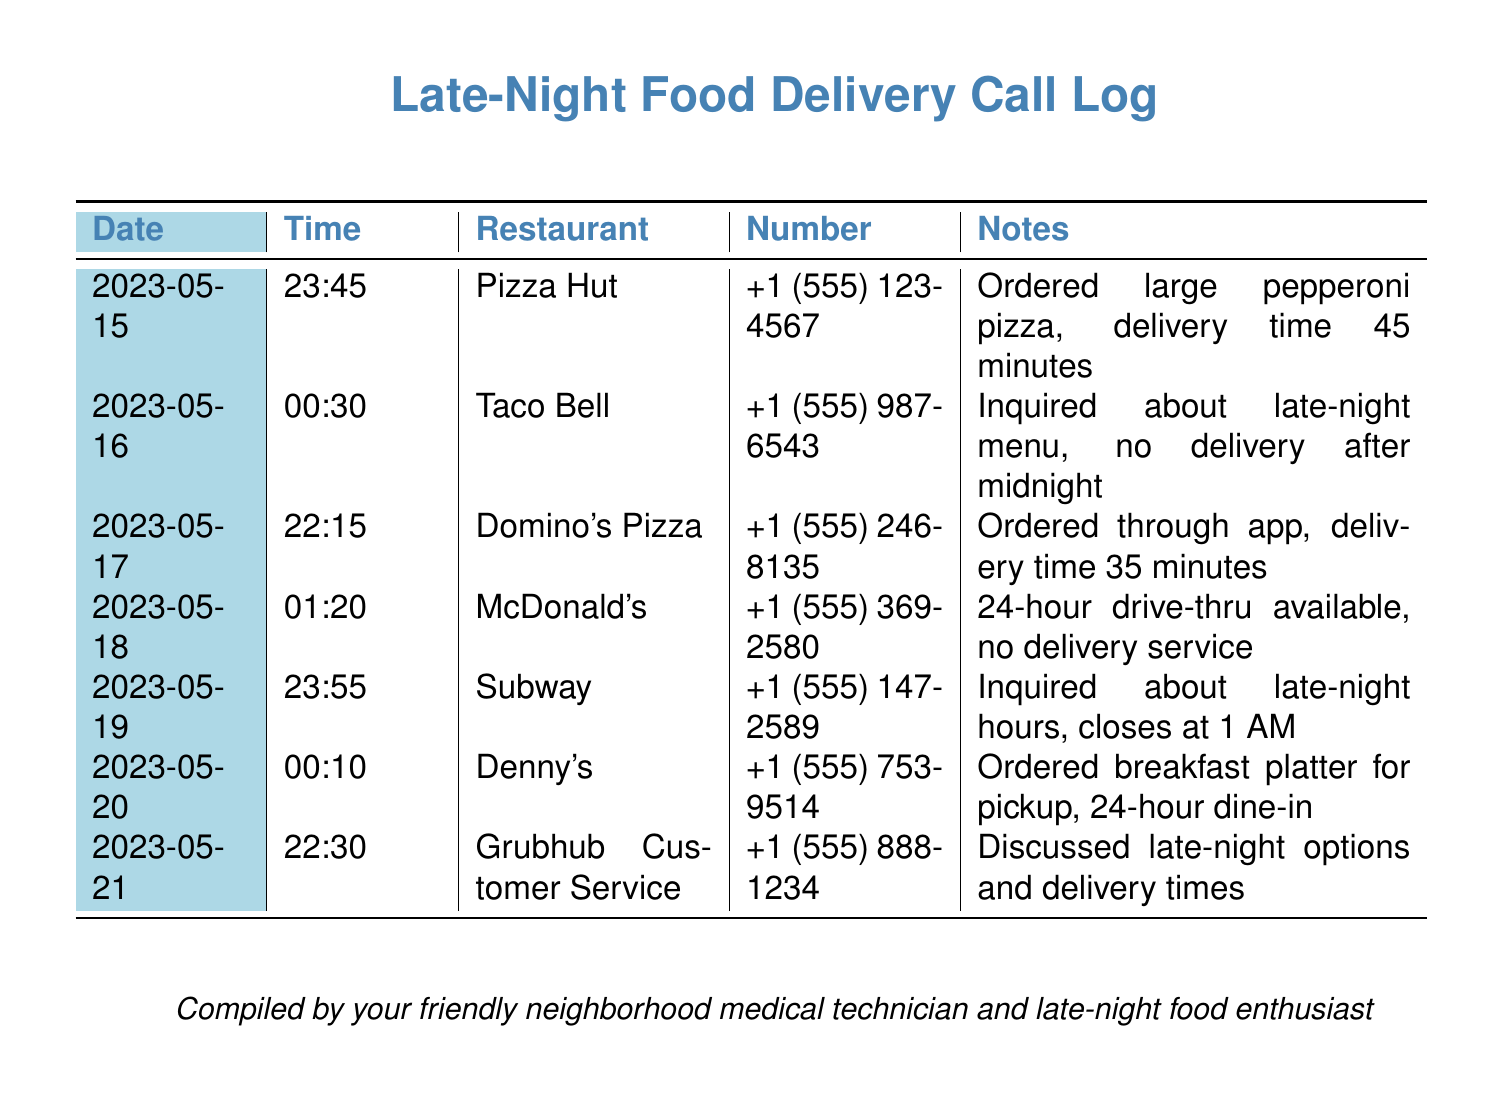what time was the pizza ordered? The pizza was ordered at 23:45 on May 15, 2023.
Answer: 23:45 which restaurant had no delivery after midnight? The restaurant that had no delivery after midnight was Taco Bell.
Answer: Taco Bell what is the delivery time for Domino's Pizza? The delivery time for Domino's Pizza is 35 minutes based on the call log entry.
Answer: 35 minutes which restaurant is open 24 hours but only for drive-thru? The restaurant that is open 24 hours for drive-thru only is McDonald's.
Answer: McDonald's when does Subway close? Subway closes at 1 AM as indicated in the call notes.
Answer: 1 AM how many phone numbers are listed in the document? There are seven unique phone numbers listed in the call log.
Answer: 7 what was discussed with Grubhub Customer Service? The discussion with Grubhub Customer Service was about late-night options and delivery times.
Answer: Late-night options and delivery times which restaurant offered a breakfast platter for pickup? The restaurant that offered a breakfast platter for pickup is Denny's.
Answer: Denny's on what date was the call made to inquire about late-night hours? The call to inquire about late-night hours was made on May 19, 2023.
Answer: May 19, 2023 